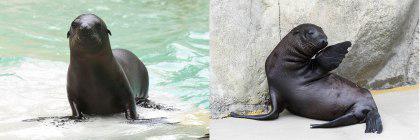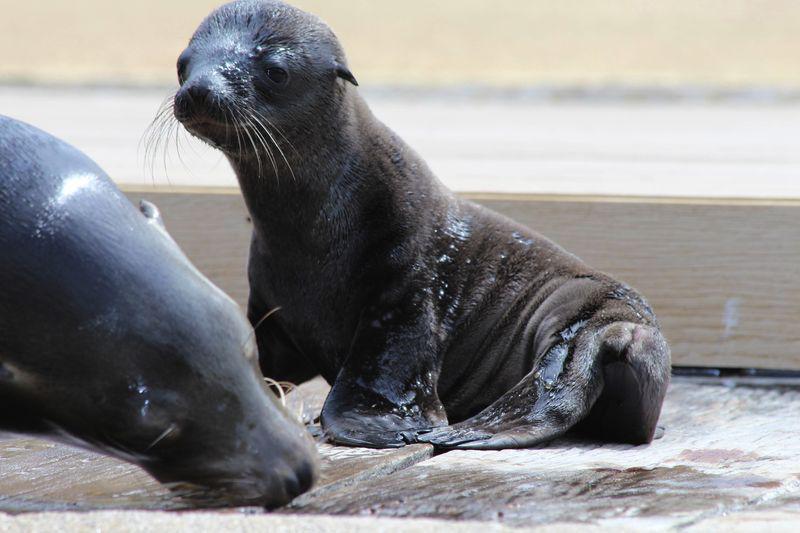The first image is the image on the left, the second image is the image on the right. Assess this claim about the two images: "There are exactly three sea lions in total.". Correct or not? Answer yes or no. No. 